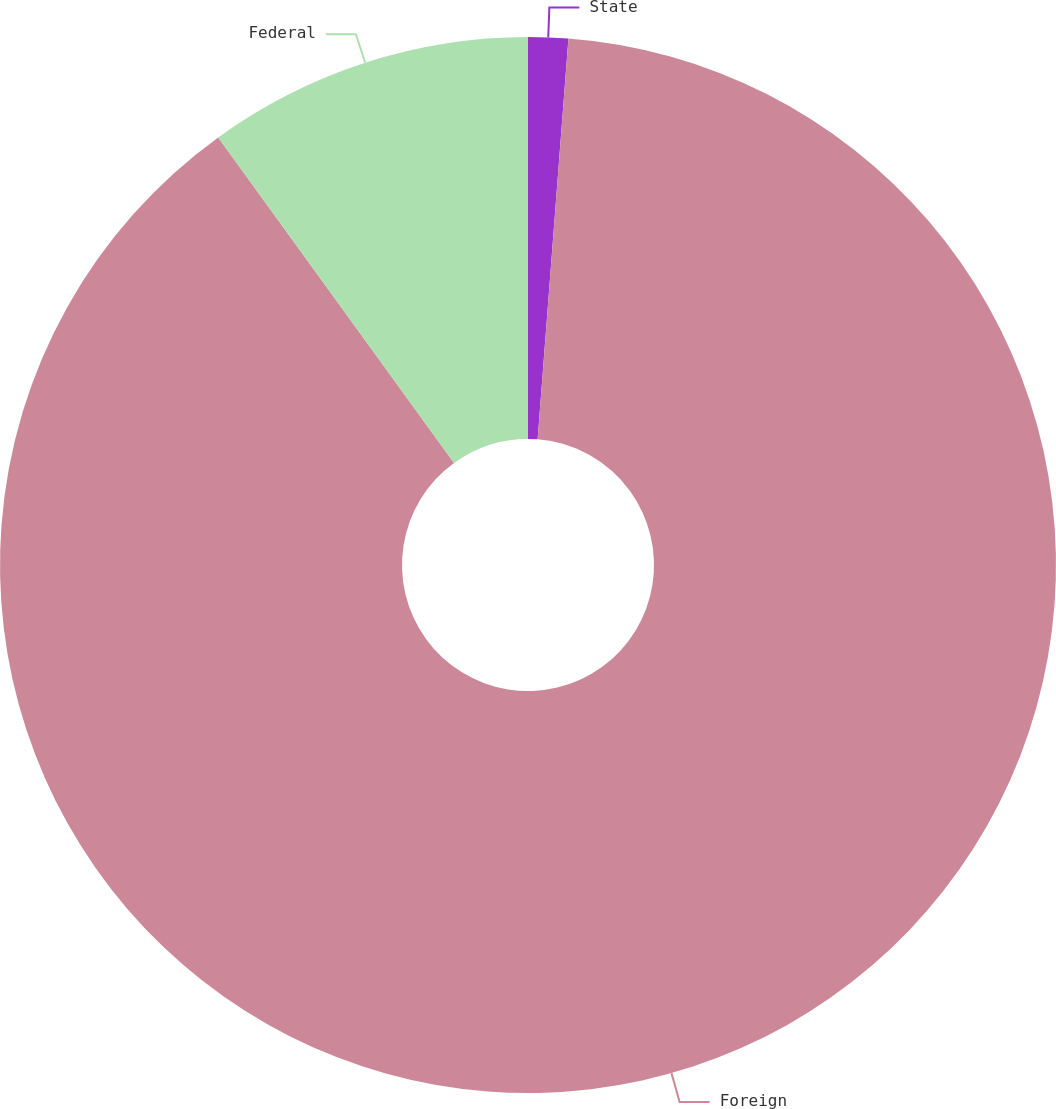<chart> <loc_0><loc_0><loc_500><loc_500><pie_chart><fcel>State<fcel>Foreign<fcel>Federal<nl><fcel>1.22%<fcel>88.8%<fcel>9.98%<nl></chart> 